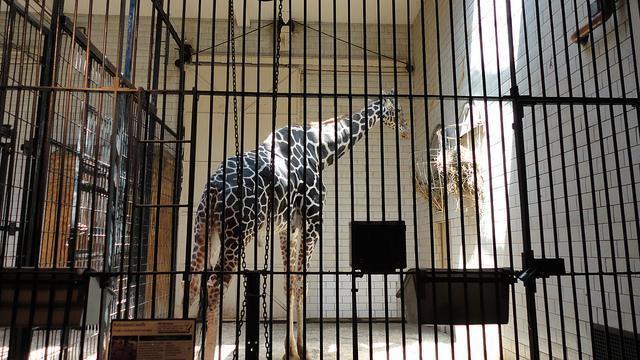How many people are pictured?
Give a very brief answer. 0. 